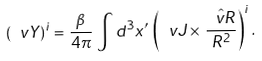Convert formula to latex. <formula><loc_0><loc_0><loc_500><loc_500>( \ v Y ) ^ { i } = \frac { \beta } { 4 \pi } \, \int d ^ { 3 } x ^ { \prime } \, \left ( \ v J \times \, \frac { \hat { \ v R } } { R ^ { 2 } } \right ) ^ { i } .</formula> 